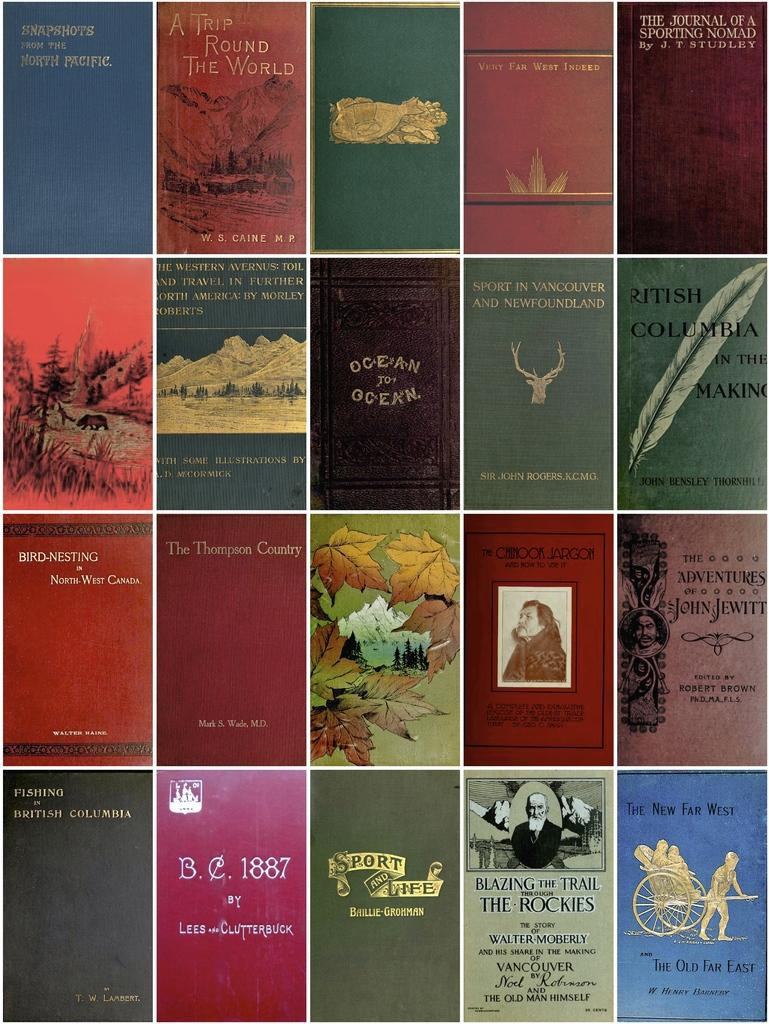<image>
Write a terse but informative summary of the picture. Ocean To Ocean is laid out above a book with a forest theme. 